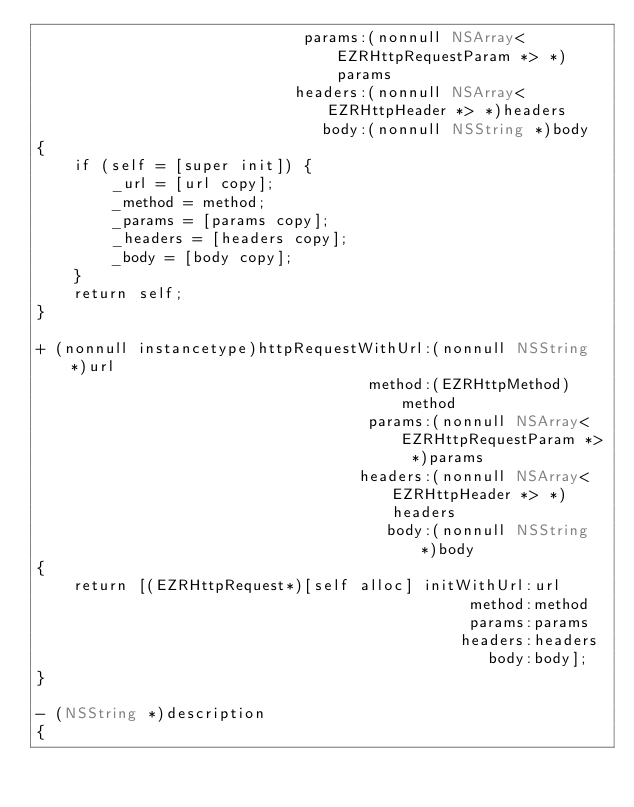Convert code to text. <code><loc_0><loc_0><loc_500><loc_500><_ObjectiveC_>                             params:(nonnull NSArray<EZRHttpRequestParam *> *)params
                            headers:(nonnull NSArray<EZRHttpHeader *> *)headers
                               body:(nonnull NSString *)body
{
    if (self = [super init]) {
        _url = [url copy];
        _method = method;
        _params = [params copy];
        _headers = [headers copy];
        _body = [body copy];
    }
    return self;
}

+ (nonnull instancetype)httpRequestWithUrl:(nonnull NSString *)url
                                    method:(EZRHttpMethod)method
                                    params:(nonnull NSArray<EZRHttpRequestParam *> *)params
                                   headers:(nonnull NSArray<EZRHttpHeader *> *)headers
                                      body:(nonnull NSString *)body
{
    return [(EZRHttpRequest*)[self alloc] initWithUrl:url
                                               method:method
                                               params:params
                                              headers:headers
                                                 body:body];
}

- (NSString *)description
{</code> 